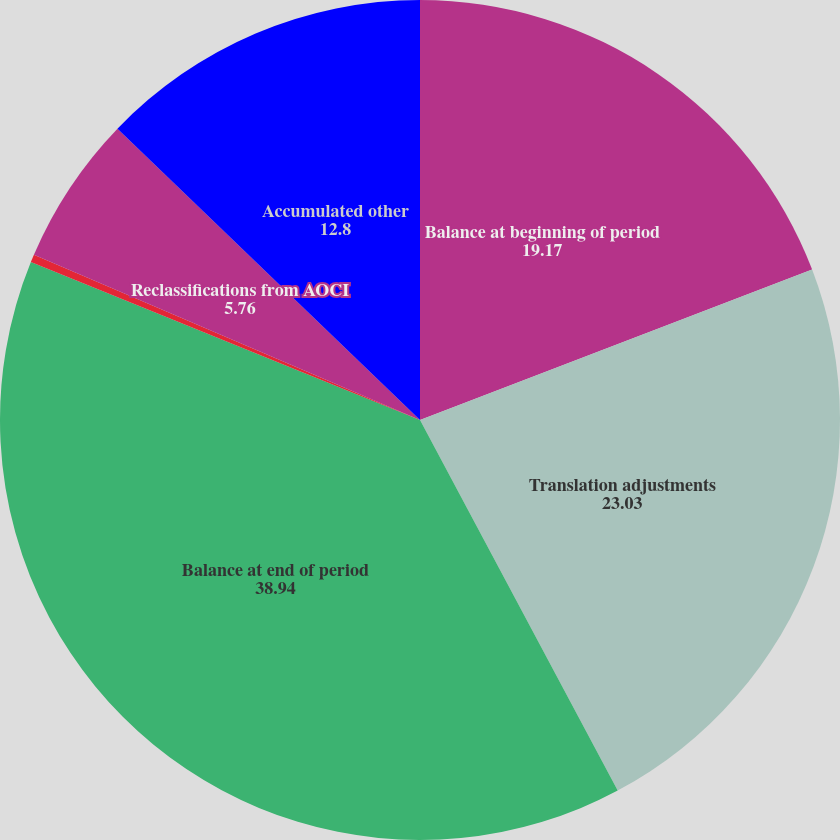<chart> <loc_0><loc_0><loc_500><loc_500><pie_chart><fcel>Balance at beginning of period<fcel>Translation adjustments<fcel>Balance at end of period<fcel>Prior service credit and other<fcel>Reclassifications from AOCI<fcel>Accumulated other<nl><fcel>19.17%<fcel>23.03%<fcel>38.94%<fcel>0.3%<fcel>5.76%<fcel>12.8%<nl></chart> 